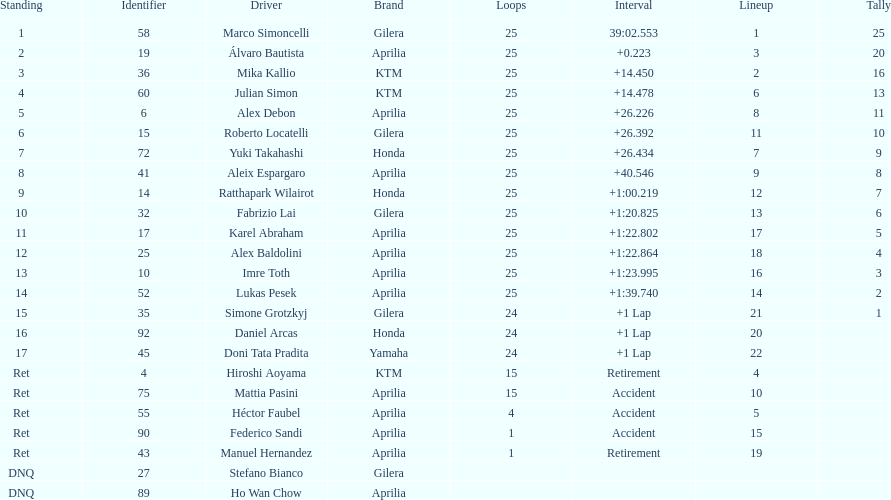The country with the most riders was Italy. 